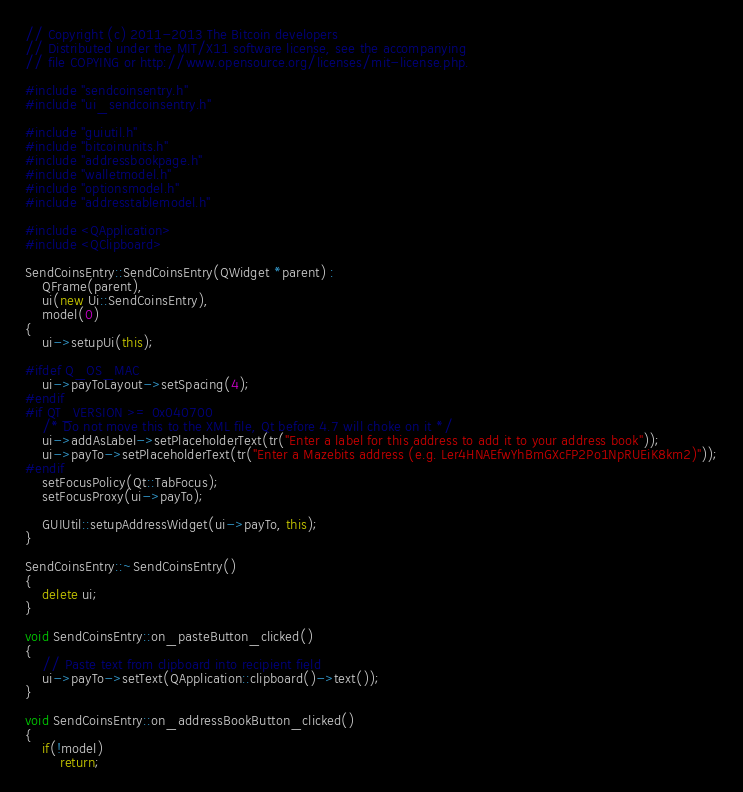<code> <loc_0><loc_0><loc_500><loc_500><_C++_>// Copyright (c) 2011-2013 The Bitcoin developers
// Distributed under the MIT/X11 software license, see the accompanying
// file COPYING or http://www.opensource.org/licenses/mit-license.php.

#include "sendcoinsentry.h"
#include "ui_sendcoinsentry.h"

#include "guiutil.h"
#include "bitcoinunits.h"
#include "addressbookpage.h"
#include "walletmodel.h"
#include "optionsmodel.h"
#include "addresstablemodel.h"

#include <QApplication>
#include <QClipboard>

SendCoinsEntry::SendCoinsEntry(QWidget *parent) :
    QFrame(parent),
    ui(new Ui::SendCoinsEntry),
    model(0)
{
    ui->setupUi(this);

#ifdef Q_OS_MAC
    ui->payToLayout->setSpacing(4);
#endif
#if QT_VERSION >= 0x040700
    /* Do not move this to the XML file, Qt before 4.7 will choke on it */
    ui->addAsLabel->setPlaceholderText(tr("Enter a label for this address to add it to your address book"));
    ui->payTo->setPlaceholderText(tr("Enter a Mazebits address (e.g. Ler4HNAEfwYhBmGXcFP2Po1NpRUEiK8km2)"));
#endif
    setFocusPolicy(Qt::TabFocus);
    setFocusProxy(ui->payTo);

    GUIUtil::setupAddressWidget(ui->payTo, this);
}

SendCoinsEntry::~SendCoinsEntry()
{
    delete ui;
}

void SendCoinsEntry::on_pasteButton_clicked()
{
    // Paste text from clipboard into recipient field
    ui->payTo->setText(QApplication::clipboard()->text());
}

void SendCoinsEntry::on_addressBookButton_clicked()
{
    if(!model)
        return;</code> 